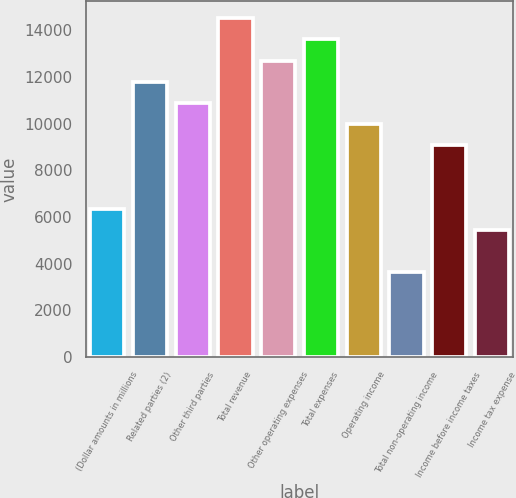Convert chart to OTSL. <chart><loc_0><loc_0><loc_500><loc_500><bar_chart><fcel>(Dollar amounts in millions<fcel>Related parties (2)<fcel>Other third parties<fcel>Total revenue<fcel>Other operating expenses<fcel>Total expenses<fcel>Operating income<fcel>Total non-operating income<fcel>Income before income taxes<fcel>Income tax expense<nl><fcel>6357.3<fcel>11804.7<fcel>10896.8<fcel>14528.4<fcel>12712.6<fcel>13620.5<fcel>9988.9<fcel>3633.6<fcel>9081<fcel>5449.4<nl></chart> 